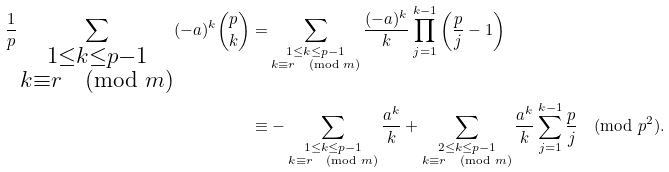<formula> <loc_0><loc_0><loc_500><loc_500>\frac { 1 } { p } \sum _ { \substack { 1 \leq k \leq p - 1 \\ k \equiv r \pmod { m } } } ( - a ) ^ { k } \binom { p } { k } = & \sum _ { \substack { 1 \leq k \leq p - 1 \\ k \equiv r \pmod { m } } } \frac { ( - a ) ^ { k } } { k } \prod _ { j = 1 } ^ { k - 1 } \left ( \frac { p } { j } - 1 \right ) \\ \equiv & - \sum _ { \substack { 1 \leq k \leq p - 1 \\ k \equiv r \pmod { m } } } \frac { a ^ { k } } { k } + \sum _ { \substack { 2 \leq k \leq p - 1 \\ k \equiv r \pmod { m } } } \frac { a ^ { k } } { k } \sum _ { j = 1 } ^ { k - 1 } \frac { p } { j } \pmod { p ^ { 2 } } .</formula> 